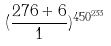Convert formula to latex. <formula><loc_0><loc_0><loc_500><loc_500>( \frac { 2 7 6 + 6 } { 1 } ) ^ { 4 5 0 ^ { 2 3 3 } }</formula> 